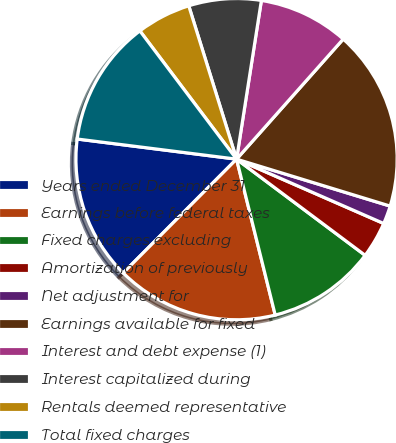<chart> <loc_0><loc_0><loc_500><loc_500><pie_chart><fcel>Years ended December 31<fcel>Earnings before federal taxes<fcel>Fixed charges excluding<fcel>Amortization of previously<fcel>Net adjustment for<fcel>Earnings available for fixed<fcel>Interest and debt expense (1)<fcel>Interest capitalized during<fcel>Rentals deemed representative<fcel>Total fixed charges<nl><fcel>14.53%<fcel>16.34%<fcel>10.91%<fcel>3.66%<fcel>1.84%<fcel>18.16%<fcel>9.09%<fcel>7.28%<fcel>5.47%<fcel>12.72%<nl></chart> 